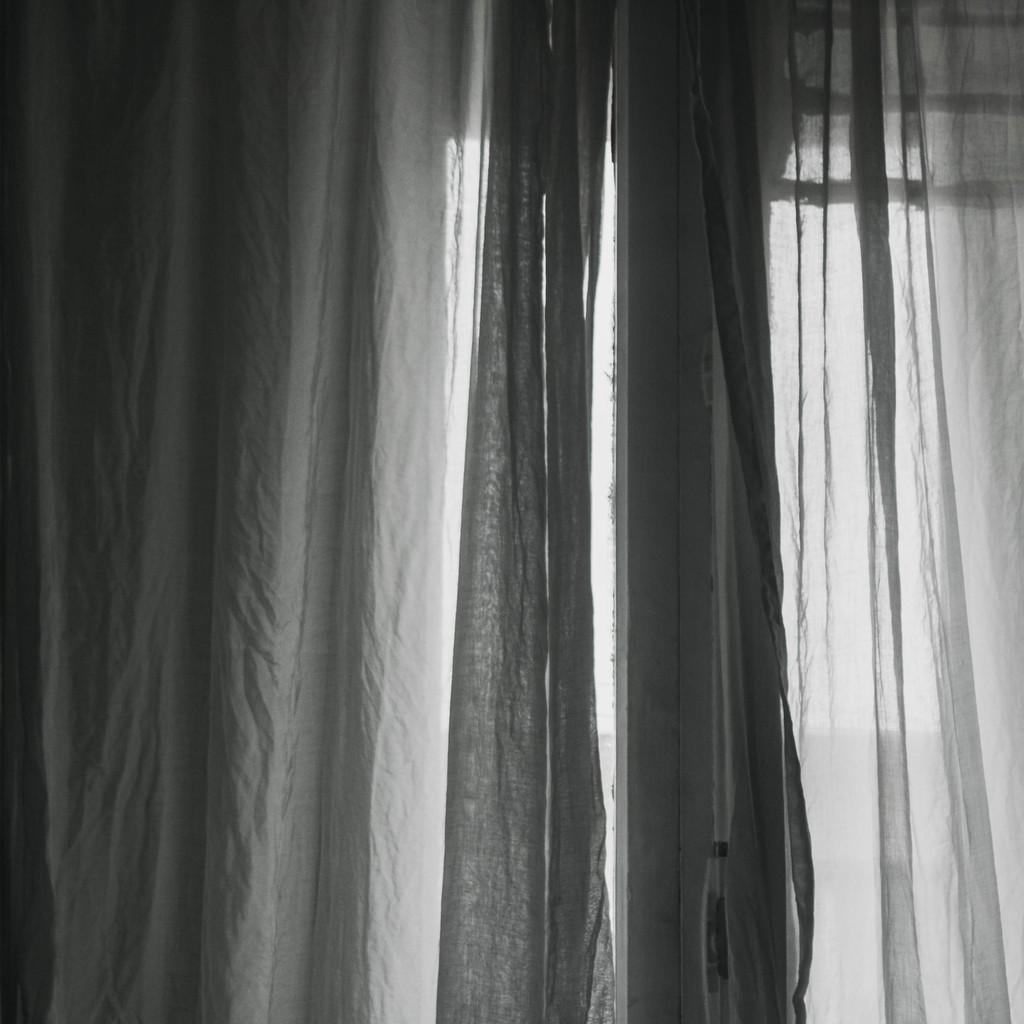What is present in the image that provides a view of the outside? There is a window in the image. What type of window covering can be seen in the image? The window has white color curtains. What is the color of the background in the image? The background of the image is white in color. What type of metal is used to make the quilt in the image? There is no quilt present in the image, and therefore no metal can be associated with it. 